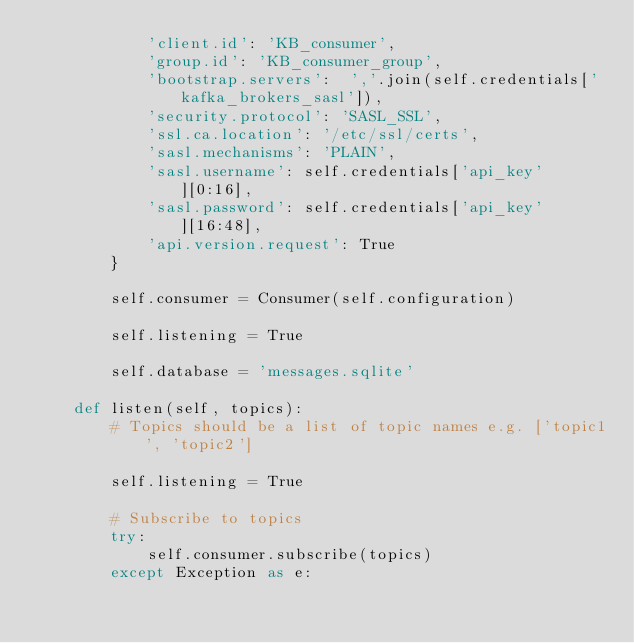Convert code to text. <code><loc_0><loc_0><loc_500><loc_500><_Python_>            'client.id': 'KB_consumer',
            'group.id': 'KB_consumer_group',
            'bootstrap.servers':  ','.join(self.credentials['kafka_brokers_sasl']),
            'security.protocol': 'SASL_SSL',
            'ssl.ca.location': '/etc/ssl/certs',
            'sasl.mechanisms': 'PLAIN',
            'sasl.username': self.credentials['api_key'][0:16],
            'sasl.password': self.credentials['api_key'][16:48],
            'api.version.request': True
        }

        self.consumer = Consumer(self.configuration)

        self.listening = True

        self.database = 'messages.sqlite'

    def listen(self, topics):
        # Topics should be a list of topic names e.g. ['topic1', 'topic2']

        self.listening = True

        # Subscribe to topics
        try:
            self.consumer.subscribe(topics)
        except Exception as e:</code> 